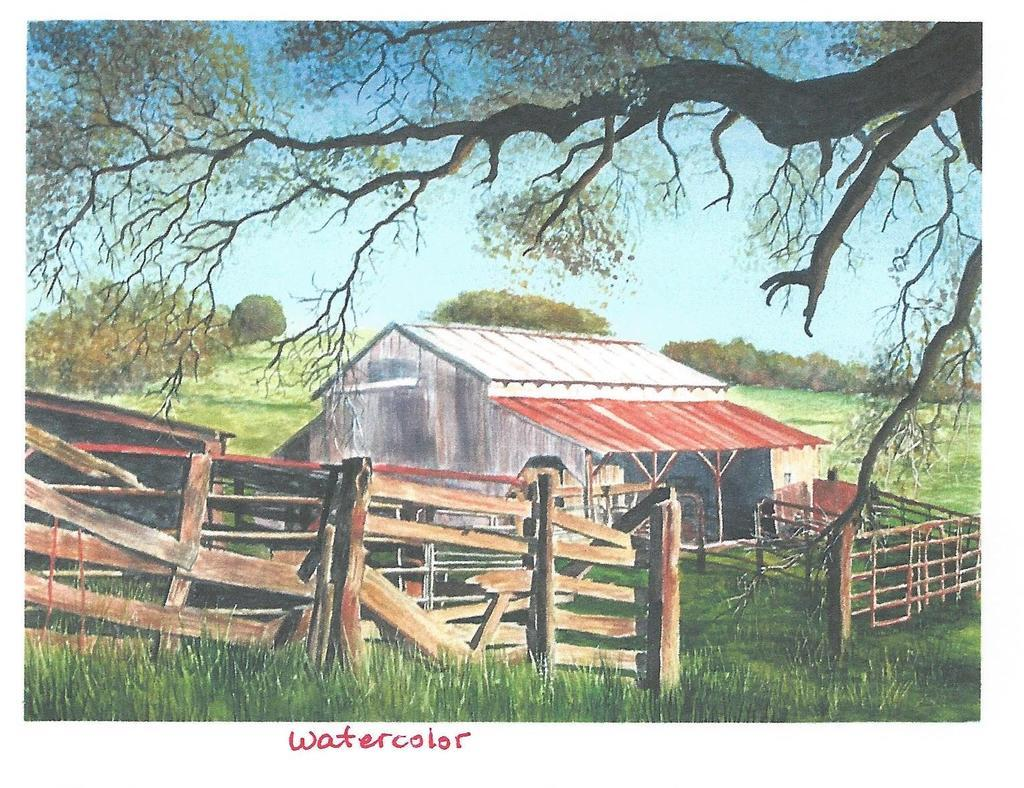<image>
Write a terse but informative summary of the picture. Waltercolor painting of and old barn and fencing in the country. 